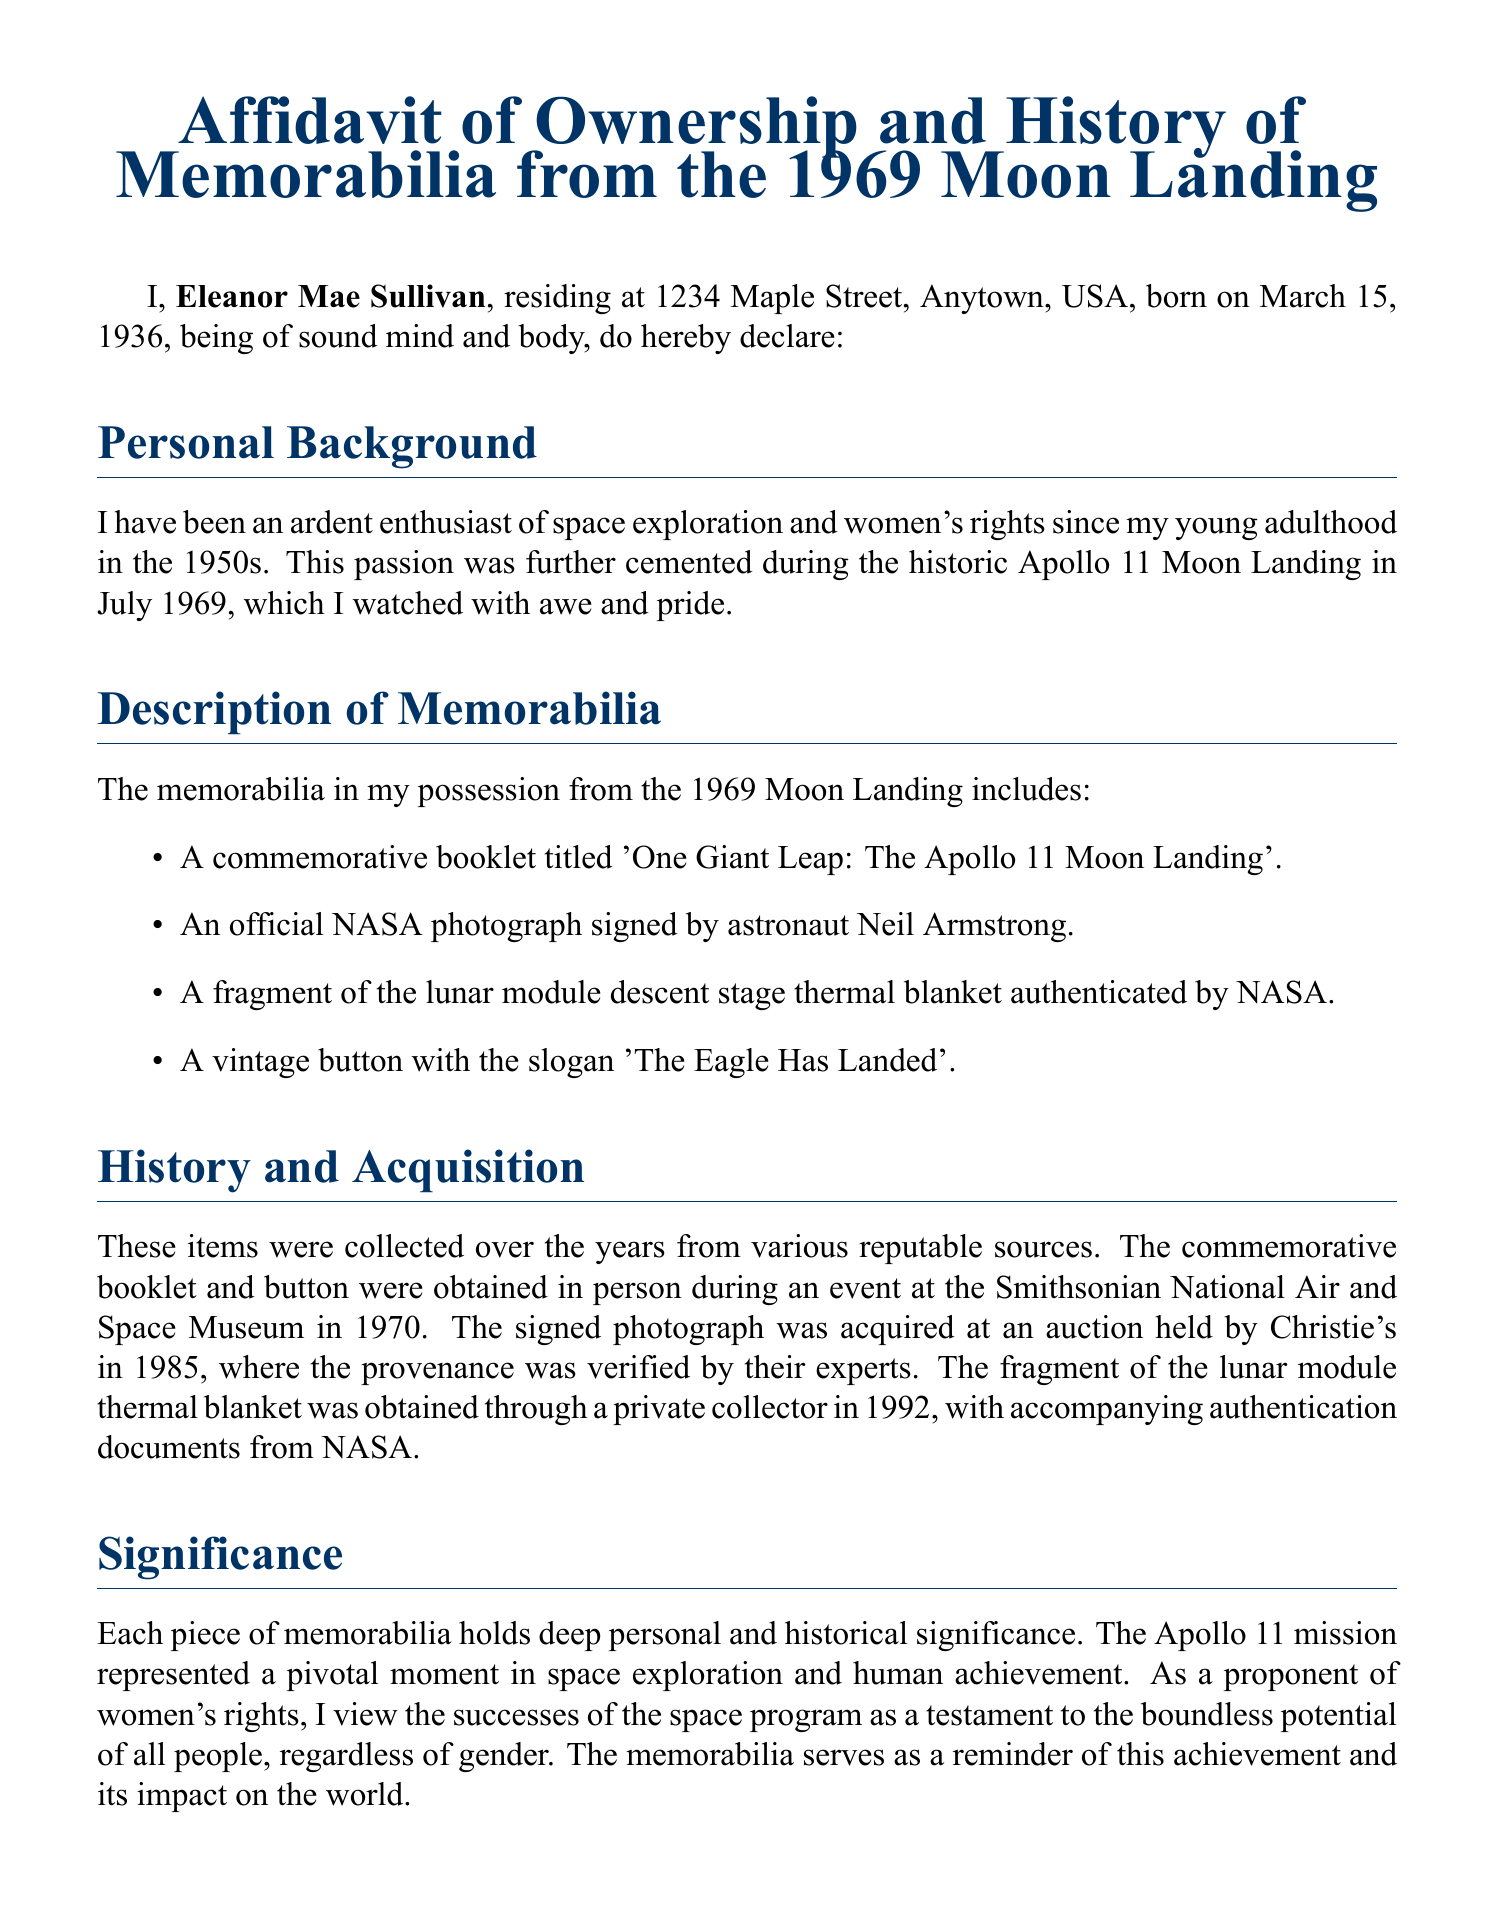What is the name of the person making the affidavit? The affidavit begins with the declaration of the person, which is Eleanor Mae Sullivan.
Answer: Eleanor Mae Sullivan What is the date of the affidavit? The date appears at the end of the document, confirming when the affidavit was signed.
Answer: October 5, 2023 How many items are listed in the memorabilia description? The document lists four items in the memorabilia section.
Answer: Four Where did Eleanor acquire the commemorative booklet and button? The event location where the booklet and button were obtained is mentioned in the history section of the affidavit.
Answer: Smithsonian National Air and Space Museum What is the significance Eleanor attributes to the Apollo 11 mission? Eleanor reflects on the wider implications of the Apollo 11 mission in relation to personal and historical significance in her statement.
Answer: Pivotal moment in space exploration and human achievement What type of authentication does the lunar module fragment have? The document specifies that the lunar module thermal blanket fragment comes with certain verification from NASA.
Answer: Authenticated by NASA What does Eleanor believe the successes of the space program represent? Eleanor infers a connection between the success of the space program and gender equality in her justification within the affidavit.
Answer: Boundless potential of all people, regardless of gender What is the address of Eleanor Mae Sullivan? The affidavit includes the residency address of the person making the statement, providing a clear location reference.
Answer: 1234 Maple Street, Anytown, USA 